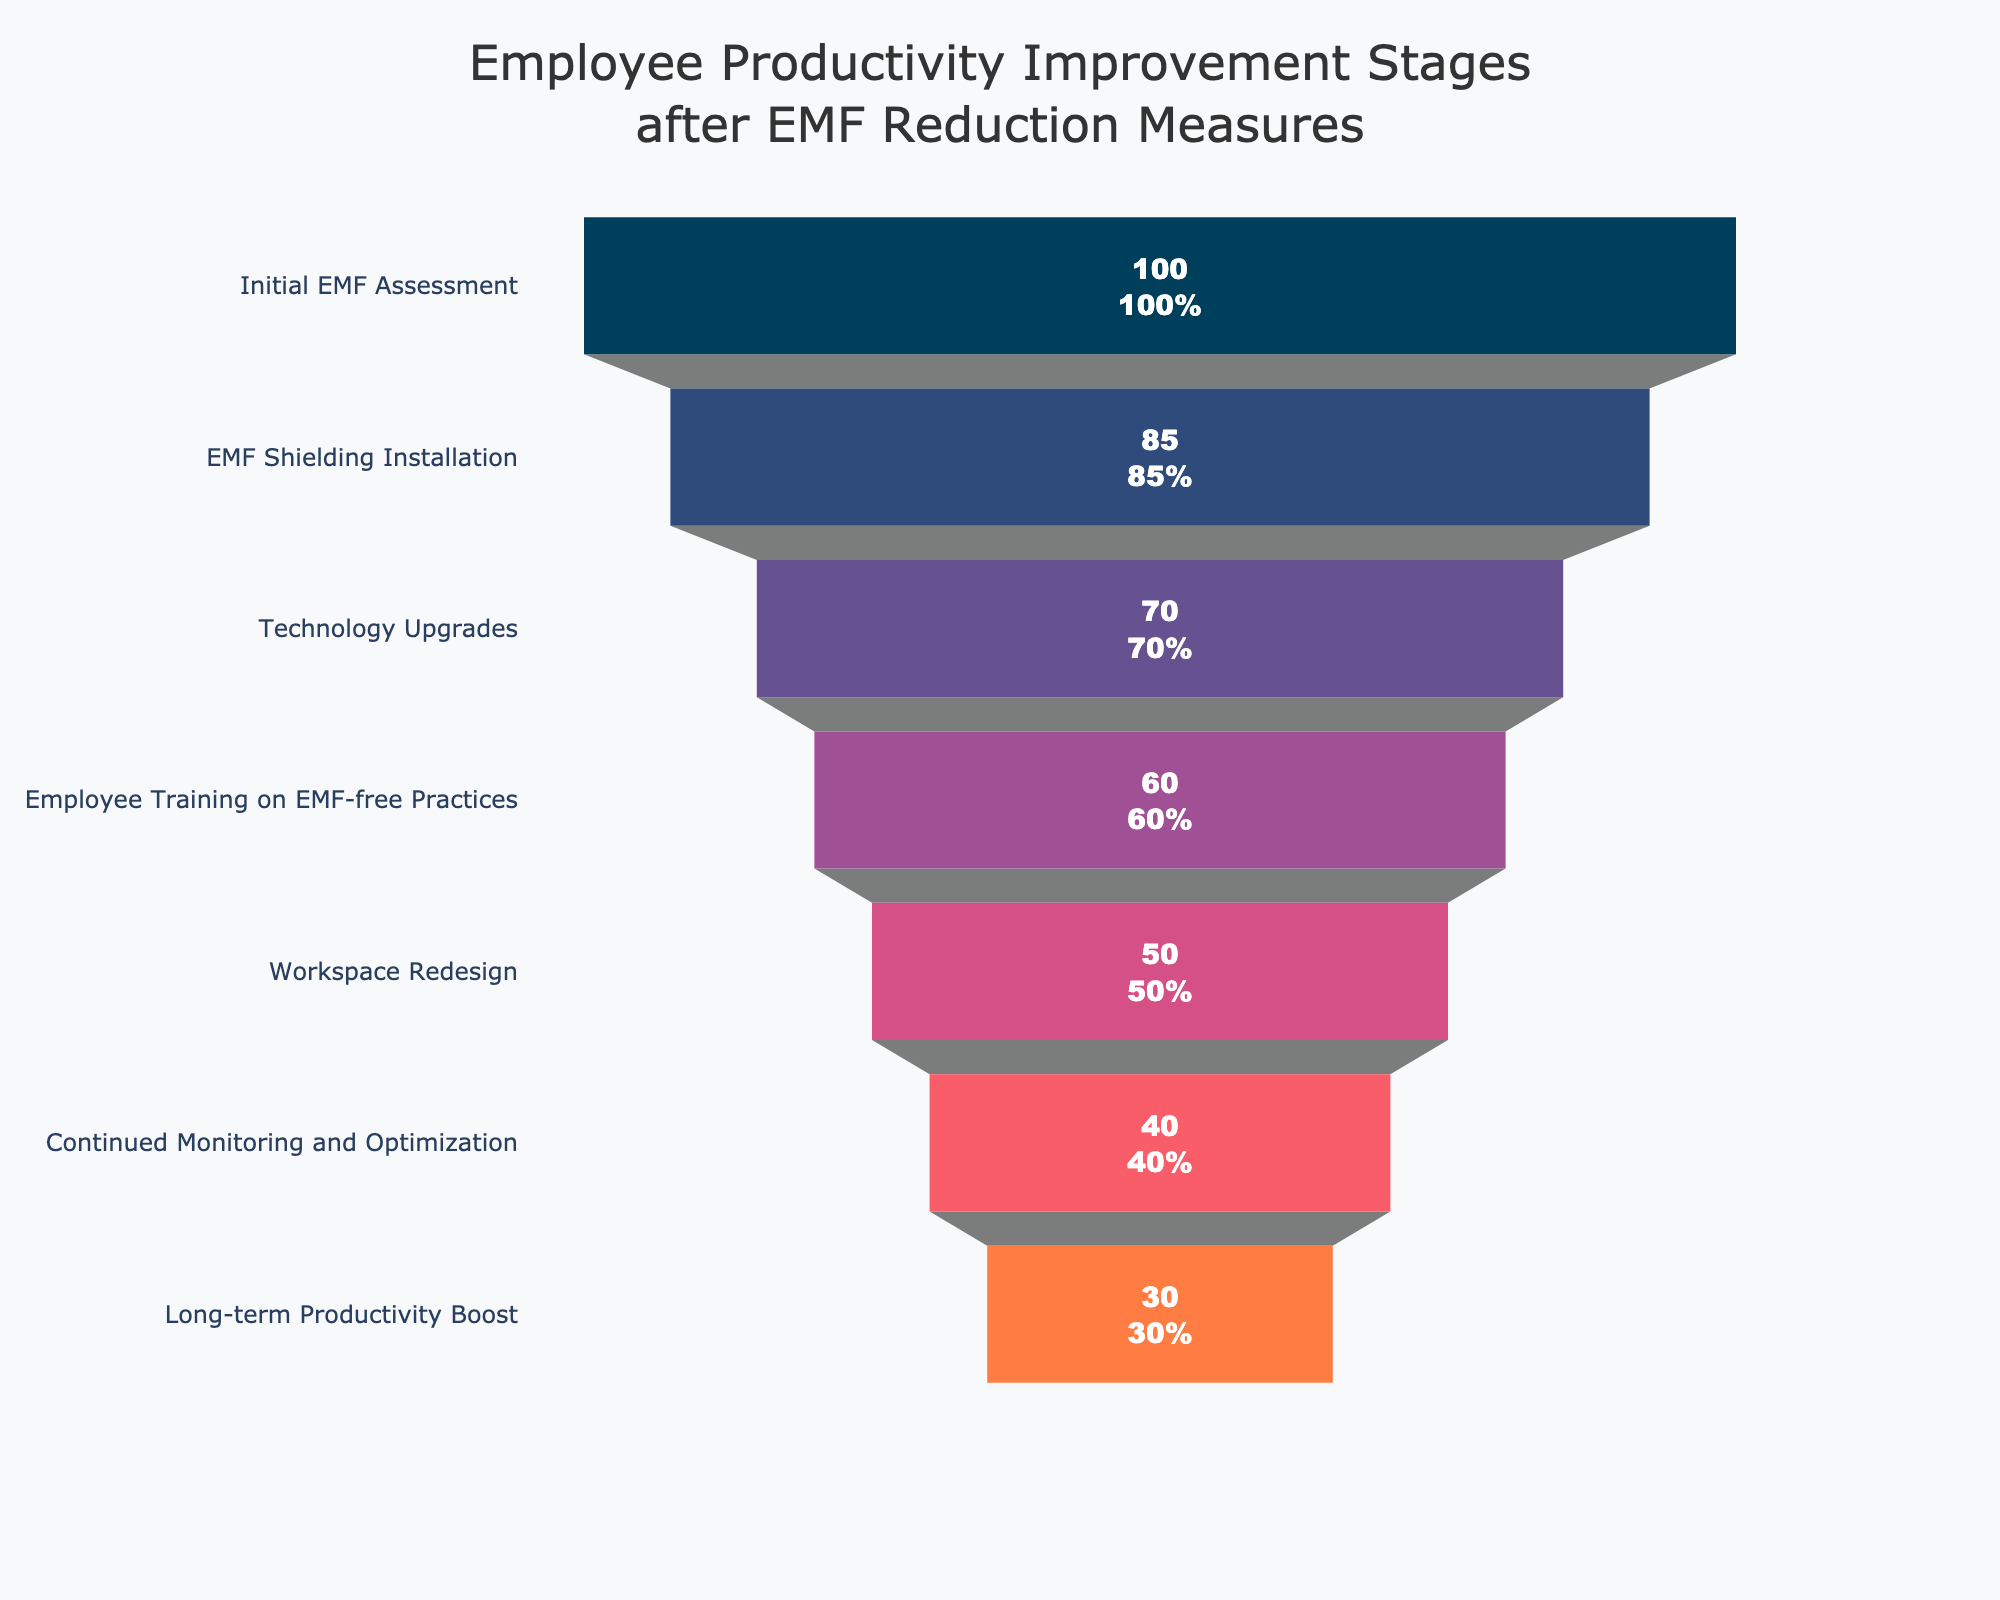What is the title of the funnel chart? The title is displayed at the top of the chart. It summarizes the focus of the chart in a concise way.
Answer: Employee Productivity Improvement Stages after EMF Reduction Measures How many stages are represented in the funnel chart? Count the number of unique stages listed along the y-axis of the chart.
Answer: 7 At which stage do the number of affected employees drop below half of the initial assessment? Compare each stage's number of employees with 50% of the initial value (100). Identify where the drop below 50 occurs.
Answer: Employee Training on EMF-free Practices What is the difference in the number of affected employees between the Technology Upgrades and Long-term Productivity Boost stages? Subtract the number of employees at the Long-term Productivity Boost stage from those at the Technology Upgrades stage (70 - 30).
Answer: 40 By what percentage did the number of affected employees decrease from the Initial EMF Assessment to the EMF Shielding Installation stage? Divide the difference between the initial assessment and shielding installation by the initial assessment, then multiply by 100% ((100 - 85)/100 * 100%).
Answer: 15% Which stage has the highest reduction in the number of employees compared to the previous stage? Calculate the difference between each successive stage's number of employees and identify the largest reduction.
Answer: Technology Upgrades (85 - 70 = 15) How do the colors used in the chart help in interpreting the data? Each stage has a distinctive color, which helps in easily distinguishing between them and following the progression through the funnel.
Answer: Distinctive colors for each stage aid interpretation Between which two stages is the employee reduction the smallest? Compare the reductions between each set of consecutive stages and find the smallest difference.
Answer: Continued Monitoring and Optimization to Long-term Productivity Boost (40 - 30 = 10) What percentage reduction in the number of affected employees is observed from the Initial EMF Assessment to Long-term Productivity Boost stages? Calculate the overall reduction percentage ((100 - 30)/100 * 100%).
Answer: 70% What is the approximate visual height of the 'Employee Training on EMF-free Practices' stage relative to the chart? This can be visually estimated by examining the segment's height compared to the entire funnel chart.
Answer: About 60% of the chart height 